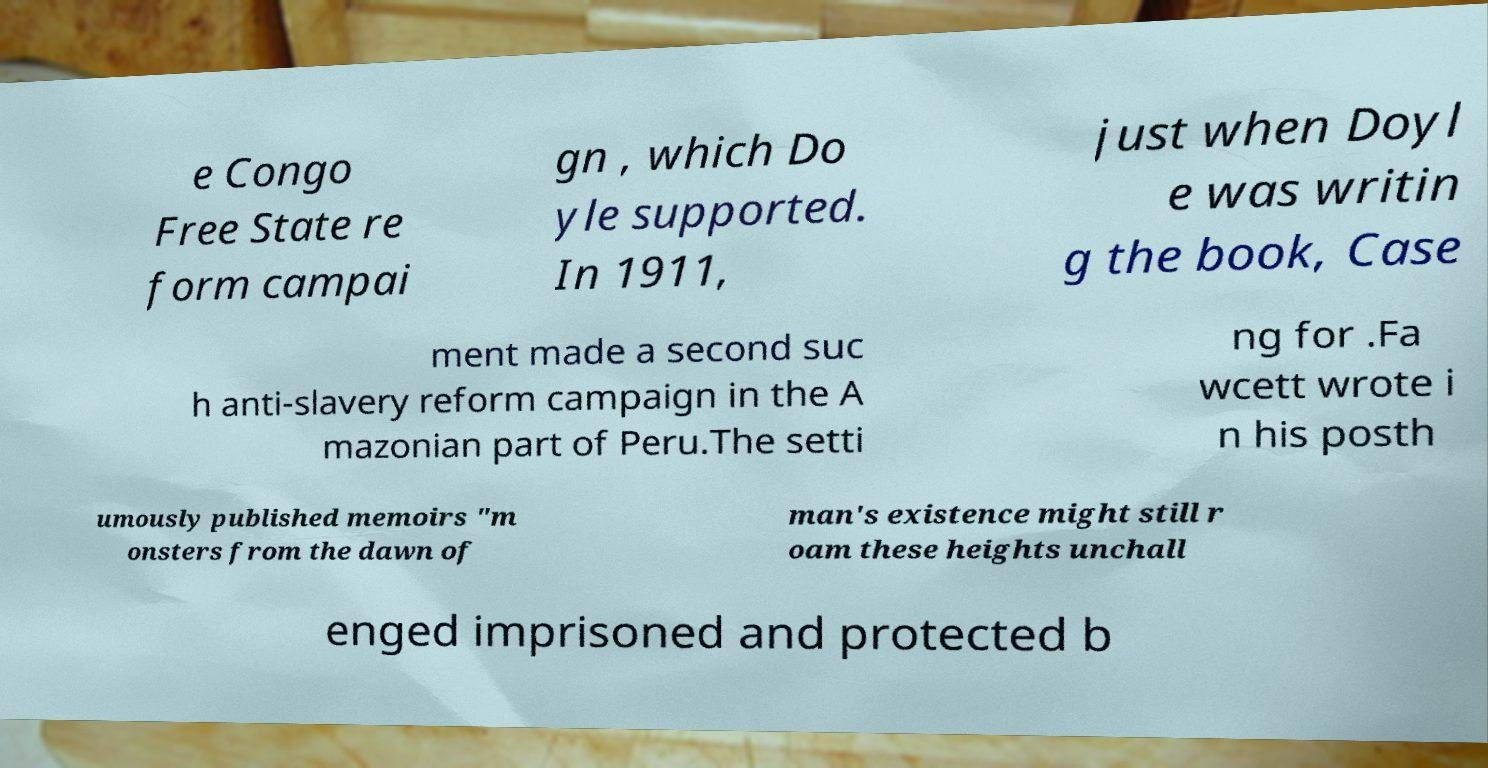There's text embedded in this image that I need extracted. Can you transcribe it verbatim? e Congo Free State re form campai gn , which Do yle supported. In 1911, just when Doyl e was writin g the book, Case ment made a second suc h anti-slavery reform campaign in the A mazonian part of Peru.The setti ng for .Fa wcett wrote i n his posth umously published memoirs "m onsters from the dawn of man's existence might still r oam these heights unchall enged imprisoned and protected b 